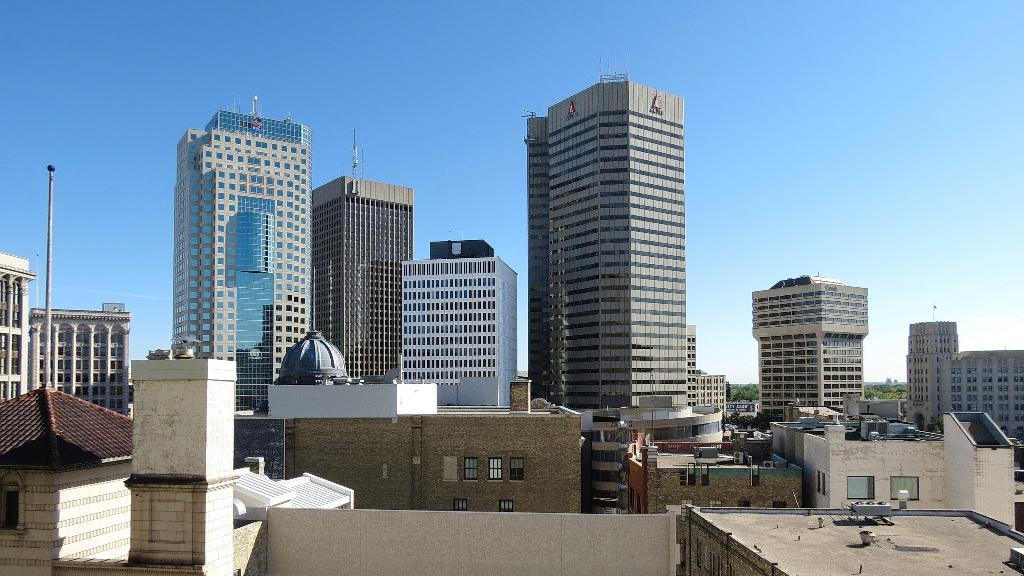What type of structures can be seen in the image? There are buildings and towers in the image. Can you describe any other objects in the image? There is a pole in the image. What can be seen in the background of the image? The sky is visible in the image. How many clovers are growing on the roof of the tallest building in the image? There are no clovers visible in the image, as it features buildings, towers, a pole, and the sky. 